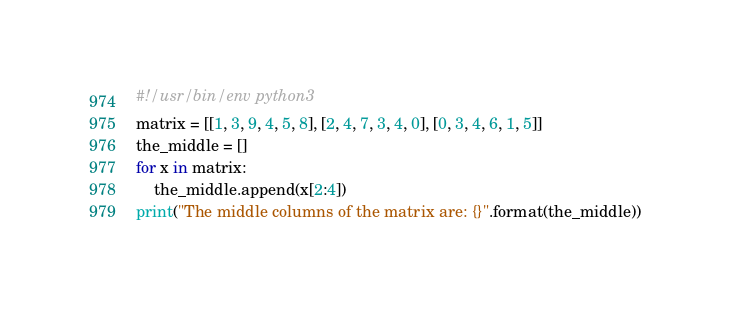Convert code to text. <code><loc_0><loc_0><loc_500><loc_500><_Python_>#!/usr/bin/env python3
matrix = [[1, 3, 9, 4, 5, 8], [2, 4, 7, 3, 4, 0], [0, 3, 4, 6, 1, 5]]
the_middle = []
for x in matrix:
    the_middle.append(x[2:4])
print("The middle columns of the matrix are: {}".format(the_middle))
</code> 